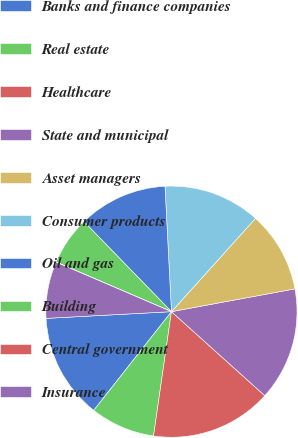<chart> <loc_0><loc_0><loc_500><loc_500><pie_chart><fcel>Banks and finance companies<fcel>Real estate<fcel>Healthcare<fcel>State and municipal<fcel>Asset managers<fcel>Consumer products<fcel>Oil and gas<fcel>Building<fcel>Central government<fcel>Insurance<nl><fcel>13.53%<fcel>8.34%<fcel>15.61%<fcel>14.57%<fcel>10.42%<fcel>12.49%<fcel>11.45%<fcel>6.26%<fcel>0.02%<fcel>7.3%<nl></chart> 